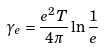<formula> <loc_0><loc_0><loc_500><loc_500>\gamma _ { e } = \frac { e ^ { 2 } T } { 4 \pi } \ln \frac { 1 } { e }</formula> 